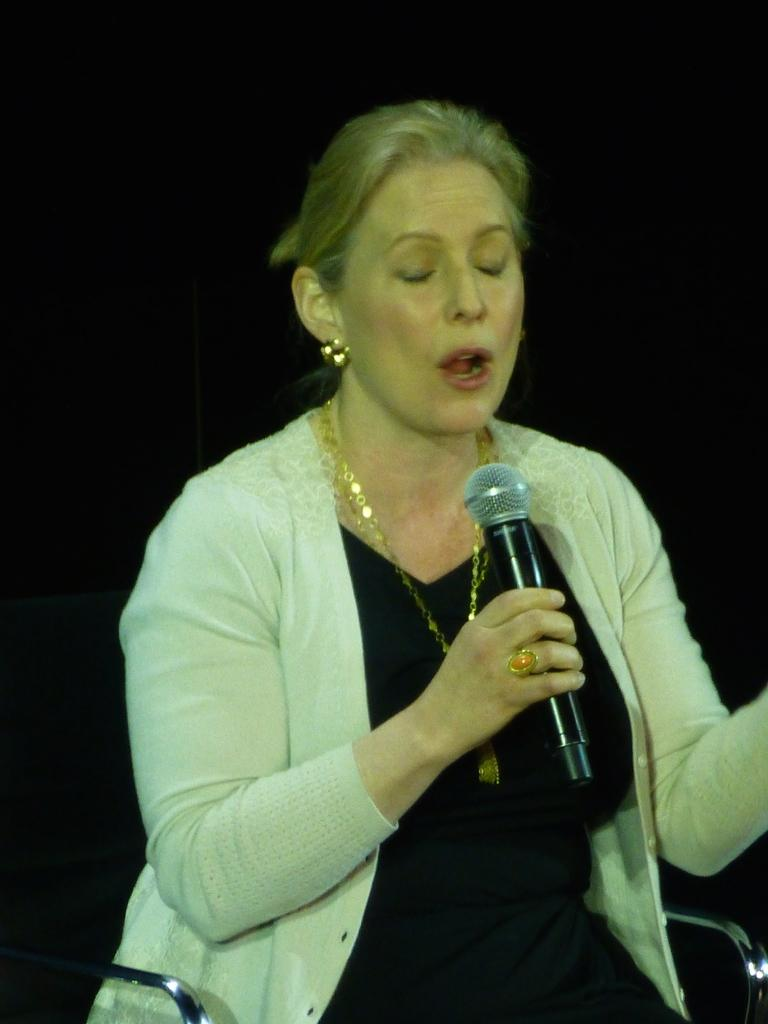What is the person in the image doing? The person is sitting on a chair in the image. What object is the person holding in her hand? The person is holding a mic in her hand. What is the person wearing? The person is wearing clothes and jewelry. What type of grass can be seen growing on the person's head in the image? There is no grass present in the image; the person is wearing clothes and jewelry, and there is no mention of grass or any other vegetation. 